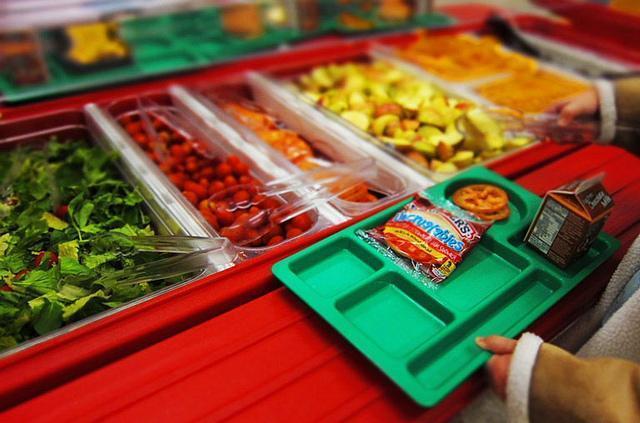How many people are visible?
Give a very brief answer. 1. How many pizza slices are missing from the tray?
Give a very brief answer. 0. 